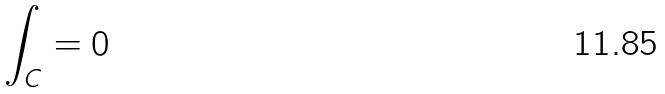Convert formula to latex. <formula><loc_0><loc_0><loc_500><loc_500>\int _ { C } = 0</formula> 